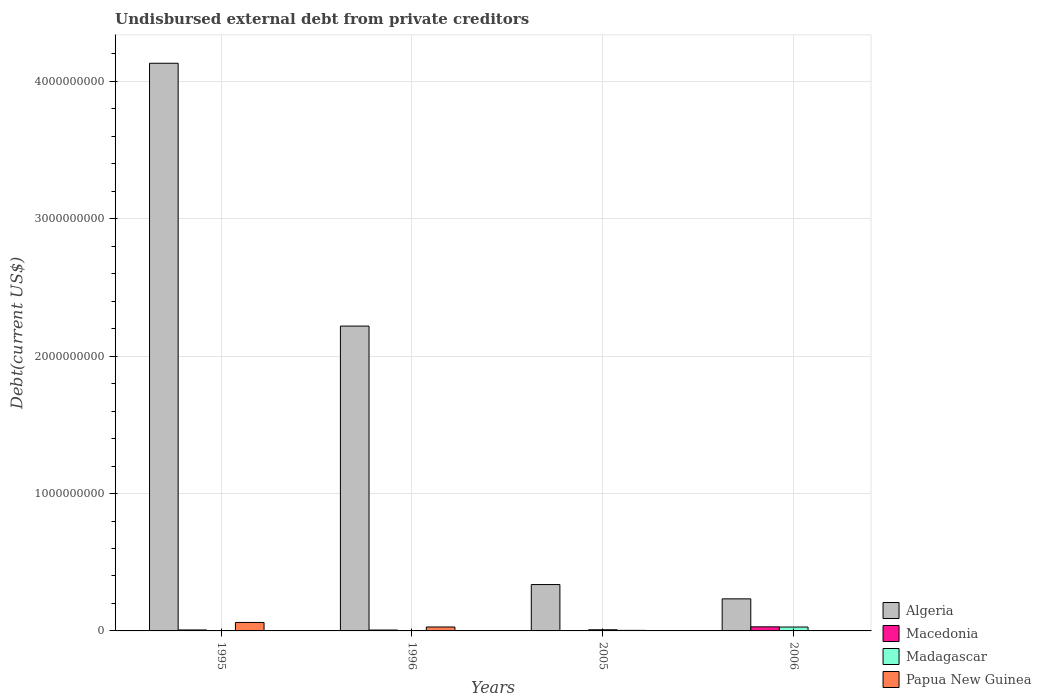How many groups of bars are there?
Make the answer very short. 4. Are the number of bars per tick equal to the number of legend labels?
Make the answer very short. Yes. How many bars are there on the 1st tick from the left?
Give a very brief answer. 4. What is the total debt in Macedonia in 2006?
Provide a short and direct response. 2.97e+07. Across all years, what is the maximum total debt in Algeria?
Give a very brief answer. 4.13e+09. Across all years, what is the minimum total debt in Madagascar?
Your answer should be compact. 2.44e+05. What is the total total debt in Madagascar in the graph?
Provide a short and direct response. 3.75e+07. What is the difference between the total debt in Macedonia in 1995 and that in 2006?
Offer a terse response. -2.27e+07. What is the difference between the total debt in Papua New Guinea in 2006 and the total debt in Macedonia in 1996?
Ensure brevity in your answer.  -6.11e+06. What is the average total debt in Papua New Guinea per year?
Give a very brief answer. 2.36e+07. In the year 1996, what is the difference between the total debt in Macedonia and total debt in Algeria?
Your answer should be very brief. -2.21e+09. In how many years, is the total debt in Macedonia greater than 3000000000 US$?
Provide a succinct answer. 0. What is the ratio of the total debt in Papua New Guinea in 2005 to that in 2006?
Offer a terse response. 12.25. Is the total debt in Madagascar in 1995 less than that in 2006?
Ensure brevity in your answer.  Yes. Is the difference between the total debt in Macedonia in 1995 and 2005 greater than the difference between the total debt in Algeria in 1995 and 2005?
Your answer should be very brief. No. What is the difference between the highest and the second highest total debt in Macedonia?
Provide a succinct answer. 2.27e+07. What is the difference between the highest and the lowest total debt in Macedonia?
Ensure brevity in your answer.  2.70e+07. In how many years, is the total debt in Madagascar greater than the average total debt in Madagascar taken over all years?
Offer a terse response. 1. What does the 4th bar from the left in 2006 represents?
Make the answer very short. Papua New Guinea. What does the 3rd bar from the right in 1996 represents?
Keep it short and to the point. Macedonia. Are all the bars in the graph horizontal?
Offer a very short reply. No. Are the values on the major ticks of Y-axis written in scientific E-notation?
Offer a very short reply. No. Does the graph contain grids?
Ensure brevity in your answer.  Yes. Where does the legend appear in the graph?
Your response must be concise. Bottom right. How many legend labels are there?
Make the answer very short. 4. How are the legend labels stacked?
Ensure brevity in your answer.  Vertical. What is the title of the graph?
Ensure brevity in your answer.  Undisbursed external debt from private creditors. What is the label or title of the X-axis?
Provide a short and direct response. Years. What is the label or title of the Y-axis?
Make the answer very short. Debt(current US$). What is the Debt(current US$) of Algeria in 1995?
Give a very brief answer. 4.13e+09. What is the Debt(current US$) in Macedonia in 1995?
Ensure brevity in your answer.  6.98e+06. What is the Debt(current US$) in Madagascar in 1995?
Keep it short and to the point. 4.83e+05. What is the Debt(current US$) of Papua New Guinea in 1995?
Your answer should be very brief. 6.15e+07. What is the Debt(current US$) in Algeria in 1996?
Give a very brief answer. 2.22e+09. What is the Debt(current US$) in Macedonia in 1996?
Keep it short and to the point. 6.43e+06. What is the Debt(current US$) in Madagascar in 1996?
Ensure brevity in your answer.  2.44e+05. What is the Debt(current US$) in Papua New Guinea in 1996?
Your response must be concise. 2.86e+07. What is the Debt(current US$) in Algeria in 2005?
Provide a succinct answer. 3.37e+08. What is the Debt(current US$) in Macedonia in 2005?
Provide a succinct answer. 2.72e+06. What is the Debt(current US$) in Madagascar in 2005?
Ensure brevity in your answer.  8.50e+06. What is the Debt(current US$) of Papua New Guinea in 2005?
Provide a succinct answer. 3.91e+06. What is the Debt(current US$) of Algeria in 2006?
Your answer should be very brief. 2.33e+08. What is the Debt(current US$) in Macedonia in 2006?
Offer a very short reply. 2.97e+07. What is the Debt(current US$) in Madagascar in 2006?
Provide a short and direct response. 2.83e+07. What is the Debt(current US$) in Papua New Guinea in 2006?
Offer a very short reply. 3.19e+05. Across all years, what is the maximum Debt(current US$) of Algeria?
Offer a very short reply. 4.13e+09. Across all years, what is the maximum Debt(current US$) in Macedonia?
Offer a very short reply. 2.97e+07. Across all years, what is the maximum Debt(current US$) in Madagascar?
Keep it short and to the point. 2.83e+07. Across all years, what is the maximum Debt(current US$) in Papua New Guinea?
Keep it short and to the point. 6.15e+07. Across all years, what is the minimum Debt(current US$) in Algeria?
Provide a short and direct response. 2.33e+08. Across all years, what is the minimum Debt(current US$) in Macedonia?
Your response must be concise. 2.72e+06. Across all years, what is the minimum Debt(current US$) in Madagascar?
Make the answer very short. 2.44e+05. Across all years, what is the minimum Debt(current US$) of Papua New Guinea?
Ensure brevity in your answer.  3.19e+05. What is the total Debt(current US$) of Algeria in the graph?
Offer a terse response. 6.92e+09. What is the total Debt(current US$) of Macedonia in the graph?
Provide a succinct answer. 4.58e+07. What is the total Debt(current US$) in Madagascar in the graph?
Offer a terse response. 3.75e+07. What is the total Debt(current US$) of Papua New Guinea in the graph?
Make the answer very short. 9.44e+07. What is the difference between the Debt(current US$) in Algeria in 1995 and that in 1996?
Your response must be concise. 1.91e+09. What is the difference between the Debt(current US$) in Macedonia in 1995 and that in 1996?
Your answer should be very brief. 5.44e+05. What is the difference between the Debt(current US$) in Madagascar in 1995 and that in 1996?
Your answer should be compact. 2.39e+05. What is the difference between the Debt(current US$) of Papua New Guinea in 1995 and that in 1996?
Provide a short and direct response. 3.29e+07. What is the difference between the Debt(current US$) in Algeria in 1995 and that in 2005?
Your answer should be very brief. 3.79e+09. What is the difference between the Debt(current US$) in Macedonia in 1995 and that in 2005?
Ensure brevity in your answer.  4.25e+06. What is the difference between the Debt(current US$) of Madagascar in 1995 and that in 2005?
Your answer should be compact. -8.02e+06. What is the difference between the Debt(current US$) of Papua New Guinea in 1995 and that in 2005?
Give a very brief answer. 5.76e+07. What is the difference between the Debt(current US$) in Algeria in 1995 and that in 2006?
Your response must be concise. 3.90e+09. What is the difference between the Debt(current US$) in Macedonia in 1995 and that in 2006?
Provide a succinct answer. -2.27e+07. What is the difference between the Debt(current US$) of Madagascar in 1995 and that in 2006?
Ensure brevity in your answer.  -2.78e+07. What is the difference between the Debt(current US$) in Papua New Guinea in 1995 and that in 2006?
Your answer should be compact. 6.12e+07. What is the difference between the Debt(current US$) in Algeria in 1996 and that in 2005?
Offer a terse response. 1.88e+09. What is the difference between the Debt(current US$) in Macedonia in 1996 and that in 2005?
Provide a succinct answer. 3.71e+06. What is the difference between the Debt(current US$) in Madagascar in 1996 and that in 2005?
Offer a terse response. -8.26e+06. What is the difference between the Debt(current US$) in Papua New Guinea in 1996 and that in 2005?
Keep it short and to the point. 2.47e+07. What is the difference between the Debt(current US$) of Algeria in 1996 and that in 2006?
Offer a very short reply. 1.99e+09. What is the difference between the Debt(current US$) of Macedonia in 1996 and that in 2006?
Keep it short and to the point. -2.33e+07. What is the difference between the Debt(current US$) of Madagascar in 1996 and that in 2006?
Make the answer very short. -2.80e+07. What is the difference between the Debt(current US$) of Papua New Guinea in 1996 and that in 2006?
Offer a very short reply. 2.83e+07. What is the difference between the Debt(current US$) in Algeria in 2005 and that in 2006?
Offer a terse response. 1.04e+08. What is the difference between the Debt(current US$) in Macedonia in 2005 and that in 2006?
Offer a very short reply. -2.70e+07. What is the difference between the Debt(current US$) of Madagascar in 2005 and that in 2006?
Ensure brevity in your answer.  -1.98e+07. What is the difference between the Debt(current US$) in Papua New Guinea in 2005 and that in 2006?
Your response must be concise. 3.59e+06. What is the difference between the Debt(current US$) in Algeria in 1995 and the Debt(current US$) in Macedonia in 1996?
Your response must be concise. 4.13e+09. What is the difference between the Debt(current US$) in Algeria in 1995 and the Debt(current US$) in Madagascar in 1996?
Provide a short and direct response. 4.13e+09. What is the difference between the Debt(current US$) of Algeria in 1995 and the Debt(current US$) of Papua New Guinea in 1996?
Your response must be concise. 4.10e+09. What is the difference between the Debt(current US$) of Macedonia in 1995 and the Debt(current US$) of Madagascar in 1996?
Provide a succinct answer. 6.73e+06. What is the difference between the Debt(current US$) of Macedonia in 1995 and the Debt(current US$) of Papua New Guinea in 1996?
Give a very brief answer. -2.17e+07. What is the difference between the Debt(current US$) in Madagascar in 1995 and the Debt(current US$) in Papua New Guinea in 1996?
Your answer should be very brief. -2.81e+07. What is the difference between the Debt(current US$) in Algeria in 1995 and the Debt(current US$) in Macedonia in 2005?
Provide a short and direct response. 4.13e+09. What is the difference between the Debt(current US$) in Algeria in 1995 and the Debt(current US$) in Madagascar in 2005?
Your answer should be very brief. 4.12e+09. What is the difference between the Debt(current US$) in Algeria in 1995 and the Debt(current US$) in Papua New Guinea in 2005?
Give a very brief answer. 4.13e+09. What is the difference between the Debt(current US$) in Macedonia in 1995 and the Debt(current US$) in Madagascar in 2005?
Make the answer very short. -1.52e+06. What is the difference between the Debt(current US$) of Macedonia in 1995 and the Debt(current US$) of Papua New Guinea in 2005?
Make the answer very short. 3.07e+06. What is the difference between the Debt(current US$) of Madagascar in 1995 and the Debt(current US$) of Papua New Guinea in 2005?
Provide a short and direct response. -3.42e+06. What is the difference between the Debt(current US$) in Algeria in 1995 and the Debt(current US$) in Macedonia in 2006?
Your answer should be very brief. 4.10e+09. What is the difference between the Debt(current US$) of Algeria in 1995 and the Debt(current US$) of Madagascar in 2006?
Your answer should be very brief. 4.10e+09. What is the difference between the Debt(current US$) in Algeria in 1995 and the Debt(current US$) in Papua New Guinea in 2006?
Your response must be concise. 4.13e+09. What is the difference between the Debt(current US$) of Macedonia in 1995 and the Debt(current US$) of Madagascar in 2006?
Provide a short and direct response. -2.13e+07. What is the difference between the Debt(current US$) of Macedonia in 1995 and the Debt(current US$) of Papua New Guinea in 2006?
Offer a terse response. 6.66e+06. What is the difference between the Debt(current US$) in Madagascar in 1995 and the Debt(current US$) in Papua New Guinea in 2006?
Offer a terse response. 1.64e+05. What is the difference between the Debt(current US$) of Algeria in 1996 and the Debt(current US$) of Macedonia in 2005?
Ensure brevity in your answer.  2.22e+09. What is the difference between the Debt(current US$) in Algeria in 1996 and the Debt(current US$) in Madagascar in 2005?
Offer a terse response. 2.21e+09. What is the difference between the Debt(current US$) of Algeria in 1996 and the Debt(current US$) of Papua New Guinea in 2005?
Your response must be concise. 2.21e+09. What is the difference between the Debt(current US$) of Macedonia in 1996 and the Debt(current US$) of Madagascar in 2005?
Make the answer very short. -2.07e+06. What is the difference between the Debt(current US$) in Macedonia in 1996 and the Debt(current US$) in Papua New Guinea in 2005?
Ensure brevity in your answer.  2.52e+06. What is the difference between the Debt(current US$) of Madagascar in 1996 and the Debt(current US$) of Papua New Guinea in 2005?
Your response must be concise. -3.66e+06. What is the difference between the Debt(current US$) in Algeria in 1996 and the Debt(current US$) in Macedonia in 2006?
Make the answer very short. 2.19e+09. What is the difference between the Debt(current US$) in Algeria in 1996 and the Debt(current US$) in Madagascar in 2006?
Your response must be concise. 2.19e+09. What is the difference between the Debt(current US$) in Algeria in 1996 and the Debt(current US$) in Papua New Guinea in 2006?
Ensure brevity in your answer.  2.22e+09. What is the difference between the Debt(current US$) of Macedonia in 1996 and the Debt(current US$) of Madagascar in 2006?
Provide a short and direct response. -2.18e+07. What is the difference between the Debt(current US$) in Macedonia in 1996 and the Debt(current US$) in Papua New Guinea in 2006?
Offer a very short reply. 6.11e+06. What is the difference between the Debt(current US$) of Madagascar in 1996 and the Debt(current US$) of Papua New Guinea in 2006?
Your answer should be very brief. -7.50e+04. What is the difference between the Debt(current US$) in Algeria in 2005 and the Debt(current US$) in Macedonia in 2006?
Keep it short and to the point. 3.08e+08. What is the difference between the Debt(current US$) of Algeria in 2005 and the Debt(current US$) of Madagascar in 2006?
Offer a very short reply. 3.09e+08. What is the difference between the Debt(current US$) in Algeria in 2005 and the Debt(current US$) in Papua New Guinea in 2006?
Provide a short and direct response. 3.37e+08. What is the difference between the Debt(current US$) of Macedonia in 2005 and the Debt(current US$) of Madagascar in 2006?
Your answer should be compact. -2.55e+07. What is the difference between the Debt(current US$) in Macedonia in 2005 and the Debt(current US$) in Papua New Guinea in 2006?
Your answer should be very brief. 2.40e+06. What is the difference between the Debt(current US$) in Madagascar in 2005 and the Debt(current US$) in Papua New Guinea in 2006?
Your answer should be compact. 8.18e+06. What is the average Debt(current US$) of Algeria per year?
Your response must be concise. 1.73e+09. What is the average Debt(current US$) in Macedonia per year?
Ensure brevity in your answer.  1.15e+07. What is the average Debt(current US$) of Madagascar per year?
Your answer should be compact. 9.37e+06. What is the average Debt(current US$) of Papua New Guinea per year?
Your response must be concise. 2.36e+07. In the year 1995, what is the difference between the Debt(current US$) of Algeria and Debt(current US$) of Macedonia?
Your response must be concise. 4.12e+09. In the year 1995, what is the difference between the Debt(current US$) in Algeria and Debt(current US$) in Madagascar?
Make the answer very short. 4.13e+09. In the year 1995, what is the difference between the Debt(current US$) in Algeria and Debt(current US$) in Papua New Guinea?
Make the answer very short. 4.07e+09. In the year 1995, what is the difference between the Debt(current US$) in Macedonia and Debt(current US$) in Madagascar?
Offer a terse response. 6.49e+06. In the year 1995, what is the difference between the Debt(current US$) of Macedonia and Debt(current US$) of Papua New Guinea?
Provide a succinct answer. -5.46e+07. In the year 1995, what is the difference between the Debt(current US$) of Madagascar and Debt(current US$) of Papua New Guinea?
Keep it short and to the point. -6.10e+07. In the year 1996, what is the difference between the Debt(current US$) in Algeria and Debt(current US$) in Macedonia?
Your answer should be compact. 2.21e+09. In the year 1996, what is the difference between the Debt(current US$) in Algeria and Debt(current US$) in Madagascar?
Your response must be concise. 2.22e+09. In the year 1996, what is the difference between the Debt(current US$) of Algeria and Debt(current US$) of Papua New Guinea?
Offer a very short reply. 2.19e+09. In the year 1996, what is the difference between the Debt(current US$) of Macedonia and Debt(current US$) of Madagascar?
Your answer should be compact. 6.19e+06. In the year 1996, what is the difference between the Debt(current US$) of Macedonia and Debt(current US$) of Papua New Guinea?
Make the answer very short. -2.22e+07. In the year 1996, what is the difference between the Debt(current US$) of Madagascar and Debt(current US$) of Papua New Guinea?
Your answer should be very brief. -2.84e+07. In the year 2005, what is the difference between the Debt(current US$) of Algeria and Debt(current US$) of Macedonia?
Ensure brevity in your answer.  3.35e+08. In the year 2005, what is the difference between the Debt(current US$) of Algeria and Debt(current US$) of Madagascar?
Your response must be concise. 3.29e+08. In the year 2005, what is the difference between the Debt(current US$) in Algeria and Debt(current US$) in Papua New Guinea?
Offer a terse response. 3.34e+08. In the year 2005, what is the difference between the Debt(current US$) of Macedonia and Debt(current US$) of Madagascar?
Provide a succinct answer. -5.78e+06. In the year 2005, what is the difference between the Debt(current US$) in Macedonia and Debt(current US$) in Papua New Guinea?
Give a very brief answer. -1.19e+06. In the year 2005, what is the difference between the Debt(current US$) of Madagascar and Debt(current US$) of Papua New Guinea?
Provide a succinct answer. 4.59e+06. In the year 2006, what is the difference between the Debt(current US$) in Algeria and Debt(current US$) in Macedonia?
Keep it short and to the point. 2.04e+08. In the year 2006, what is the difference between the Debt(current US$) of Algeria and Debt(current US$) of Madagascar?
Keep it short and to the point. 2.05e+08. In the year 2006, what is the difference between the Debt(current US$) in Algeria and Debt(current US$) in Papua New Guinea?
Your answer should be compact. 2.33e+08. In the year 2006, what is the difference between the Debt(current US$) in Macedonia and Debt(current US$) in Madagascar?
Provide a succinct answer. 1.45e+06. In the year 2006, what is the difference between the Debt(current US$) of Macedonia and Debt(current US$) of Papua New Guinea?
Keep it short and to the point. 2.94e+07. In the year 2006, what is the difference between the Debt(current US$) in Madagascar and Debt(current US$) in Papua New Guinea?
Keep it short and to the point. 2.79e+07. What is the ratio of the Debt(current US$) of Algeria in 1995 to that in 1996?
Keep it short and to the point. 1.86. What is the ratio of the Debt(current US$) of Macedonia in 1995 to that in 1996?
Your answer should be very brief. 1.08. What is the ratio of the Debt(current US$) in Madagascar in 1995 to that in 1996?
Give a very brief answer. 1.98. What is the ratio of the Debt(current US$) of Papua New Guinea in 1995 to that in 1996?
Keep it short and to the point. 2.15. What is the ratio of the Debt(current US$) of Algeria in 1995 to that in 2005?
Provide a succinct answer. 12.24. What is the ratio of the Debt(current US$) in Macedonia in 1995 to that in 2005?
Keep it short and to the point. 2.56. What is the ratio of the Debt(current US$) of Madagascar in 1995 to that in 2005?
Offer a very short reply. 0.06. What is the ratio of the Debt(current US$) in Papua New Guinea in 1995 to that in 2005?
Your response must be concise. 15.74. What is the ratio of the Debt(current US$) of Algeria in 1995 to that in 2006?
Ensure brevity in your answer.  17.7. What is the ratio of the Debt(current US$) of Macedonia in 1995 to that in 2006?
Your answer should be very brief. 0.23. What is the ratio of the Debt(current US$) in Madagascar in 1995 to that in 2006?
Make the answer very short. 0.02. What is the ratio of the Debt(current US$) of Papua New Guinea in 1995 to that in 2006?
Your answer should be compact. 192.87. What is the ratio of the Debt(current US$) in Algeria in 1996 to that in 2005?
Offer a terse response. 6.57. What is the ratio of the Debt(current US$) of Macedonia in 1996 to that in 2005?
Your response must be concise. 2.36. What is the ratio of the Debt(current US$) of Madagascar in 1996 to that in 2005?
Ensure brevity in your answer.  0.03. What is the ratio of the Debt(current US$) in Papua New Guinea in 1996 to that in 2005?
Keep it short and to the point. 7.33. What is the ratio of the Debt(current US$) of Algeria in 1996 to that in 2006?
Provide a succinct answer. 9.5. What is the ratio of the Debt(current US$) in Macedonia in 1996 to that in 2006?
Give a very brief answer. 0.22. What is the ratio of the Debt(current US$) of Madagascar in 1996 to that in 2006?
Your answer should be very brief. 0.01. What is the ratio of the Debt(current US$) of Papua New Guinea in 1996 to that in 2006?
Keep it short and to the point. 89.74. What is the ratio of the Debt(current US$) in Algeria in 2005 to that in 2006?
Your answer should be very brief. 1.45. What is the ratio of the Debt(current US$) in Macedonia in 2005 to that in 2006?
Provide a succinct answer. 0.09. What is the ratio of the Debt(current US$) in Madagascar in 2005 to that in 2006?
Ensure brevity in your answer.  0.3. What is the ratio of the Debt(current US$) in Papua New Guinea in 2005 to that in 2006?
Provide a succinct answer. 12.25. What is the difference between the highest and the second highest Debt(current US$) in Algeria?
Provide a short and direct response. 1.91e+09. What is the difference between the highest and the second highest Debt(current US$) in Macedonia?
Provide a short and direct response. 2.27e+07. What is the difference between the highest and the second highest Debt(current US$) of Madagascar?
Ensure brevity in your answer.  1.98e+07. What is the difference between the highest and the second highest Debt(current US$) of Papua New Guinea?
Ensure brevity in your answer.  3.29e+07. What is the difference between the highest and the lowest Debt(current US$) of Algeria?
Your answer should be compact. 3.90e+09. What is the difference between the highest and the lowest Debt(current US$) in Macedonia?
Give a very brief answer. 2.70e+07. What is the difference between the highest and the lowest Debt(current US$) of Madagascar?
Make the answer very short. 2.80e+07. What is the difference between the highest and the lowest Debt(current US$) of Papua New Guinea?
Offer a very short reply. 6.12e+07. 